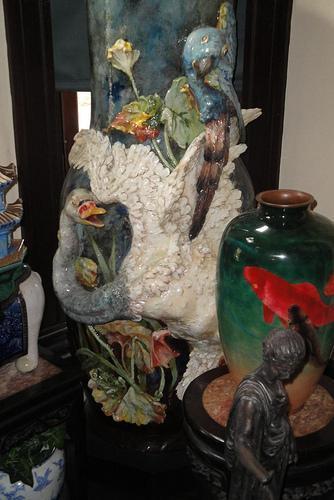How many men are wearing black shorts?
Give a very brief answer. 0. 